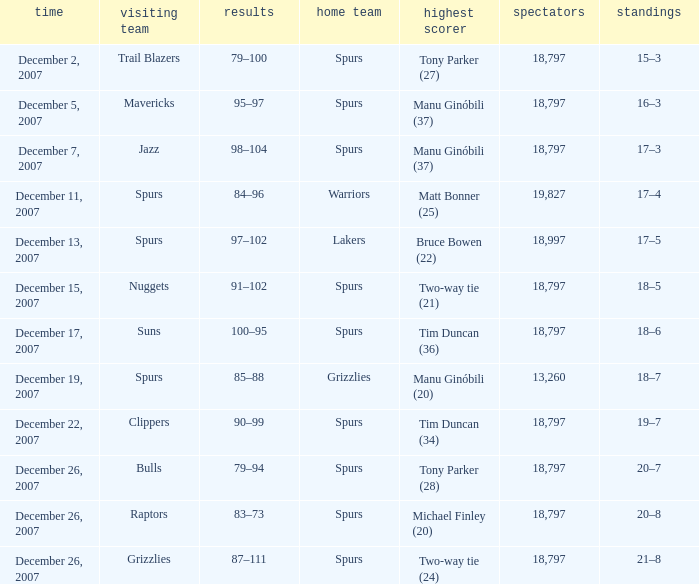What is the highest attendace of the game with the Lakers as the home team? 18997.0. 